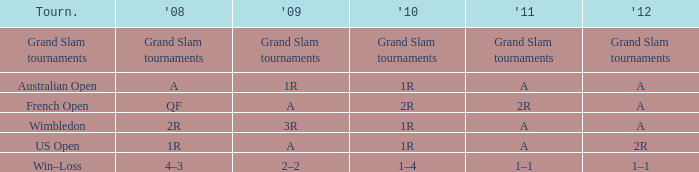Name the tournament when it has 2011 of 2r French Open. 